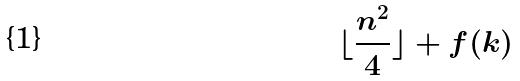Convert formula to latex. <formula><loc_0><loc_0><loc_500><loc_500>\lfloor \frac { n ^ { 2 } } { 4 } \rfloor + f ( k )</formula> 